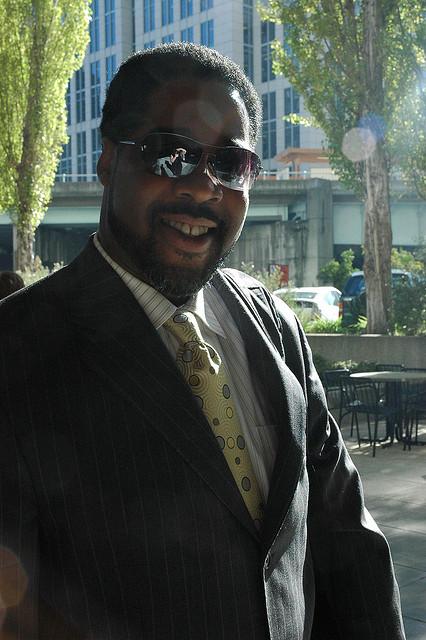What shapes are on the tie?
Be succinct. Circles. Did this man shave this morning?
Short answer required. No. What pattern is on the man's tie?
Concise answer only. Dots. What is the man wearing?
Keep it brief. Suit. 